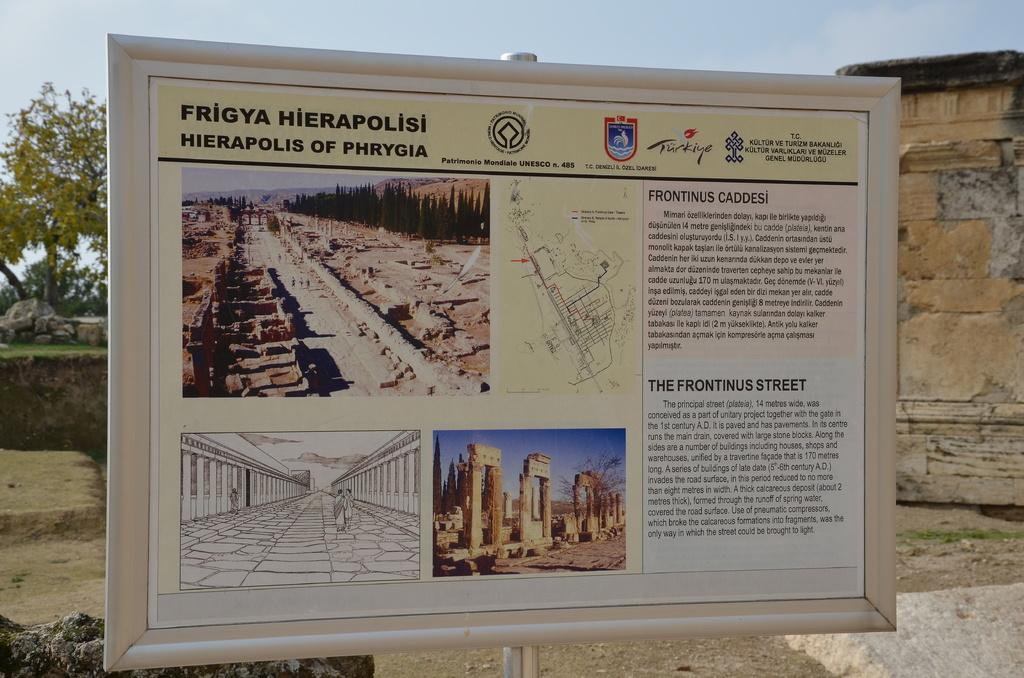<image>
Provide a brief description of the given image. A sign that says Frigya Hierapolsi on it at the top. 